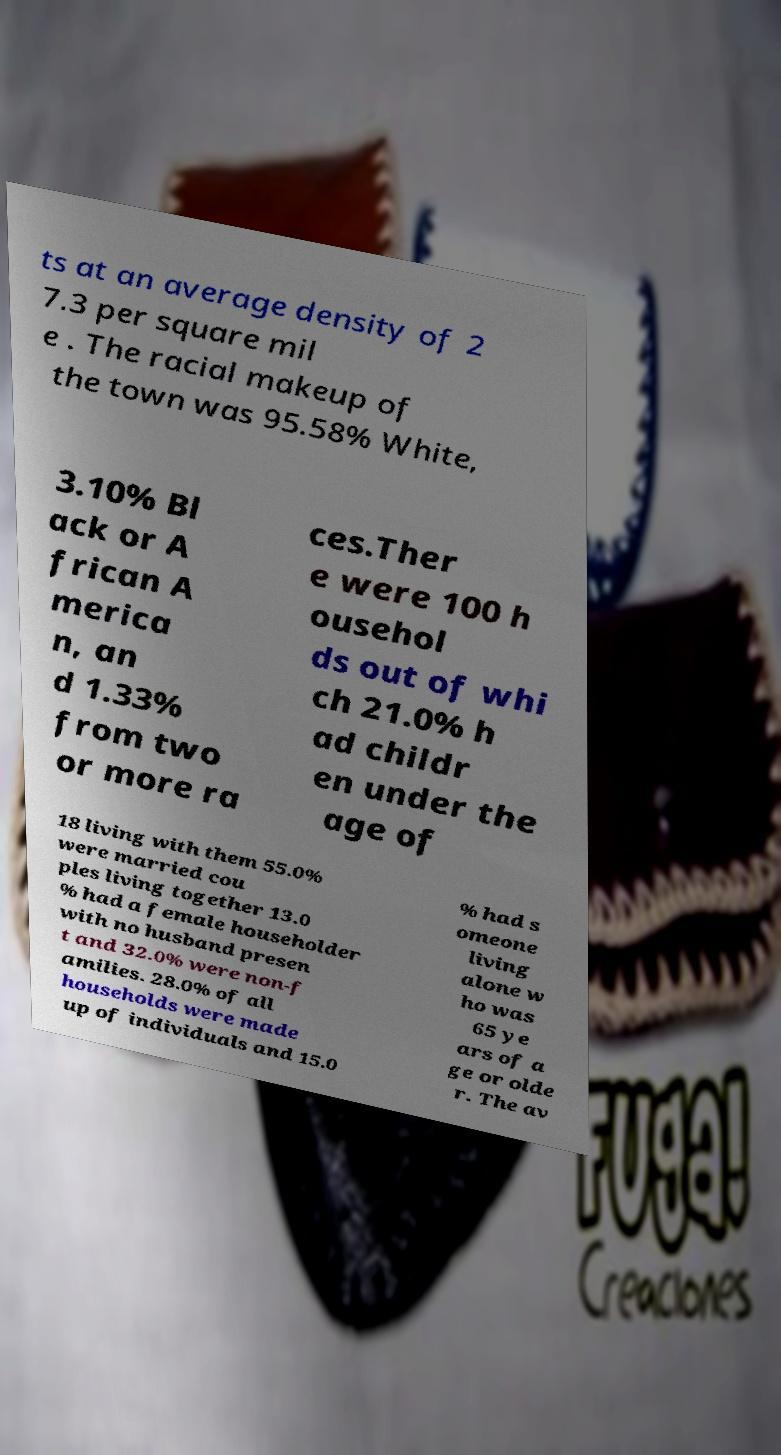For documentation purposes, I need the text within this image transcribed. Could you provide that? ts at an average density of 2 7.3 per square mil e . The racial makeup of the town was 95.58% White, 3.10% Bl ack or A frican A merica n, an d 1.33% from two or more ra ces.Ther e were 100 h ousehol ds out of whi ch 21.0% h ad childr en under the age of 18 living with them 55.0% were married cou ples living together 13.0 % had a female householder with no husband presen t and 32.0% were non-f amilies. 28.0% of all households were made up of individuals and 15.0 % had s omeone living alone w ho was 65 ye ars of a ge or olde r. The av 